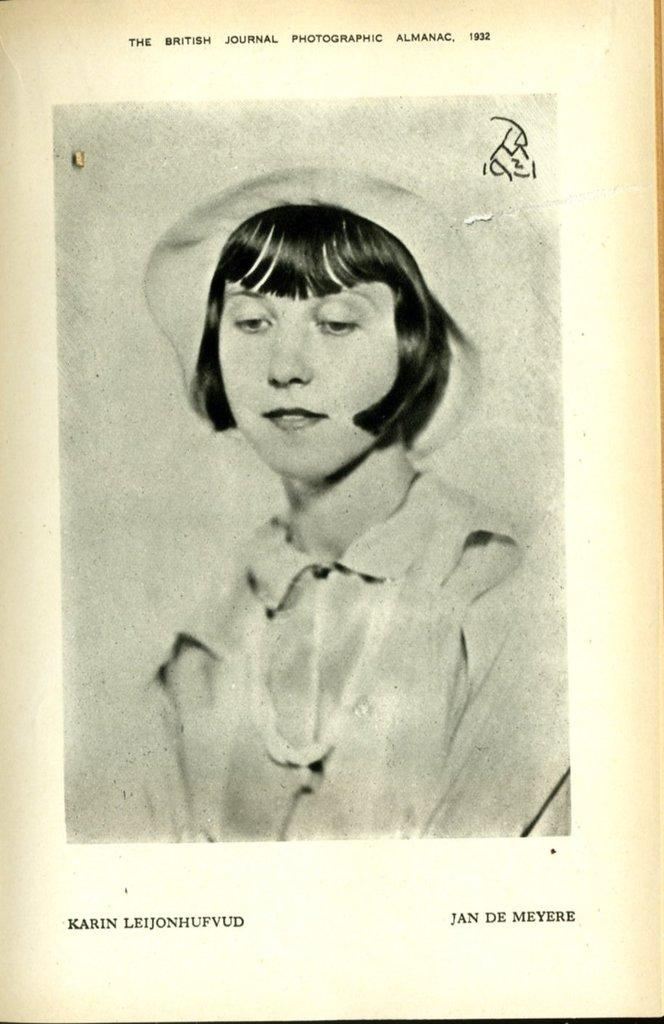What is depicted in the image? There is an image of a woman in the picture. What is written on the paper in the image? There are words and numbers on the paper. How many legs does the property have in the image? There is no property present in the image, and therefore no legs can be counted. 